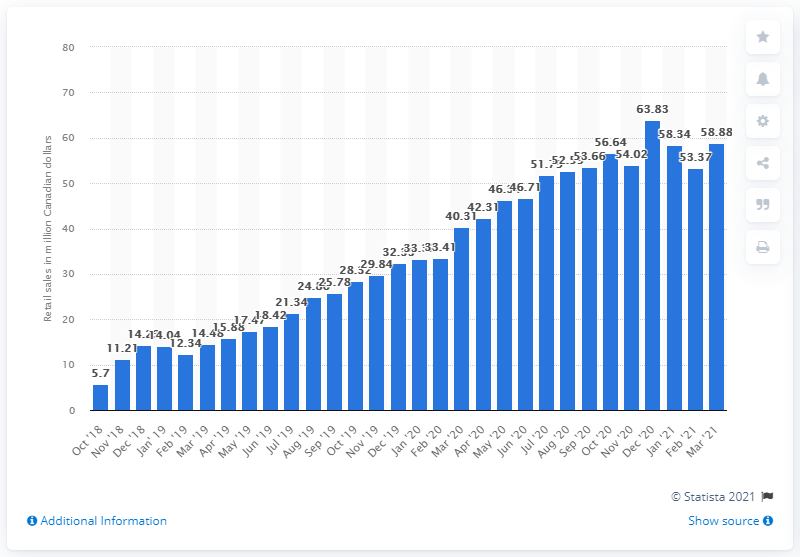Indicate a few pertinent items in this graphic. In March 2021, the highest monthly sales of cannabis in Canada were 58.88 metric tons. 